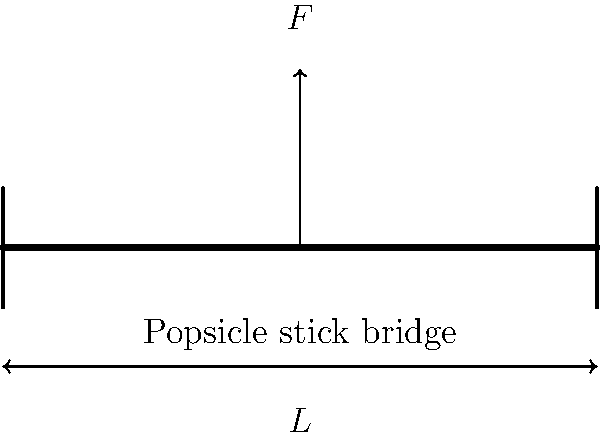You've built a miniature bridge using popsicle sticks for your childhood toy collection. The bridge spans a length $L$ of 30 cm and is subjected to a point load $F$ at its center. If each popsicle stick can withstand a maximum bending stress of 20 MPa and has a rectangular cross-section of 10 mm width and 2 mm thickness, what is the maximum load $F$ (in Newtons) that can be safely applied to the bridge? Let's approach this step-by-step:

1) First, we need to calculate the moment of inertia ($I$) for the popsicle stick:
   $I = \frac{1}{12}bh^3$, where $b$ is width and $h$ is thickness
   $I = \frac{1}{12} \times 10 \times 2^3 = 6.67 \times 10^{-12} m^4$

2) The maximum bending moment ($M_{max}$) occurs at the center of the bridge:
   $M_{max} = \frac{FL}{4}$, where $F$ is the applied load and $L$ is the span

3) The maximum bending stress ($\sigma_{max}$) is related to the maximum moment by:
   $\sigma_{max} = \frac{M_{max}y}{I}$, where $y$ is half the thickness of the stick

4) Substituting and rearranging:
   $20 \times 10^6 = \frac{FL}{4} \times \frac{1 \times 10^{-3}}{6.67 \times 10^{-12}}$

5) Solving for $F$:
   $F = \frac{20 \times 10^6 \times 4 \times 6.67 \times 10^{-12}}{0.3 \times 1 \times 10^{-3}} = 1.78 N$

Therefore, the maximum load that can be safely applied is approximately 1.78 N.
Answer: 1.78 N 